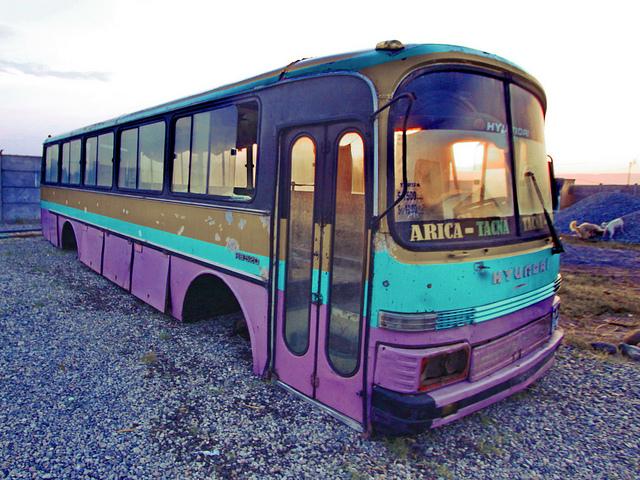How can we tell this bus won't be moving anytime soon?
Give a very brief answer. No wheels. What is a main color of the bus?
Give a very brief answer. Purple. What is the bus on top of?
Short answer required. Gravel. Why is it difficult to see in of the bus?
Short answer required. Dark. 